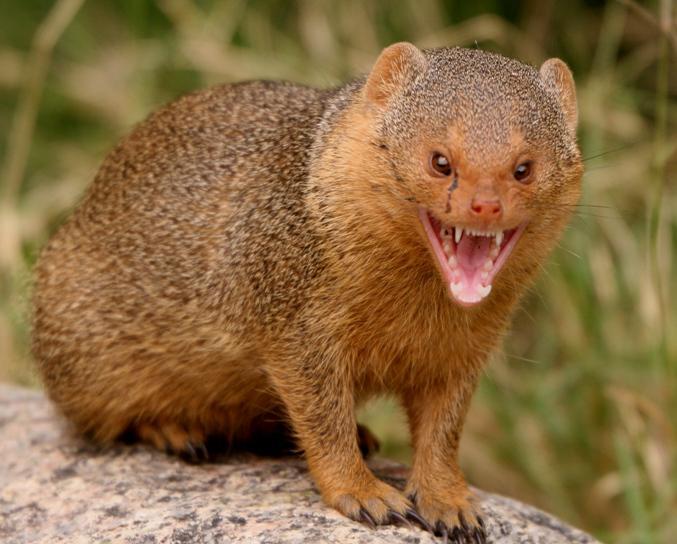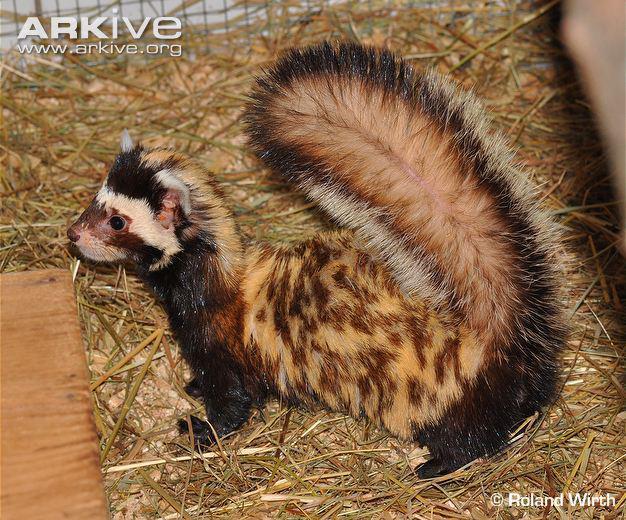The first image is the image on the left, the second image is the image on the right. For the images shown, is this caption "The right image features one ferret with spotted fur and a tail that curves inward over its back, and the left image features an animal with its front paws on a rock and its body turned rightward." true? Answer yes or no. Yes. The first image is the image on the left, the second image is the image on the right. Examine the images to the left and right. Is the description "The left and right image contains the same number of mustelids facing opposite directions." accurate? Answer yes or no. Yes. 